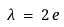Convert formula to latex. <formula><loc_0><loc_0><loc_500><loc_500>\lambda \, = \, 2 \, e</formula> 